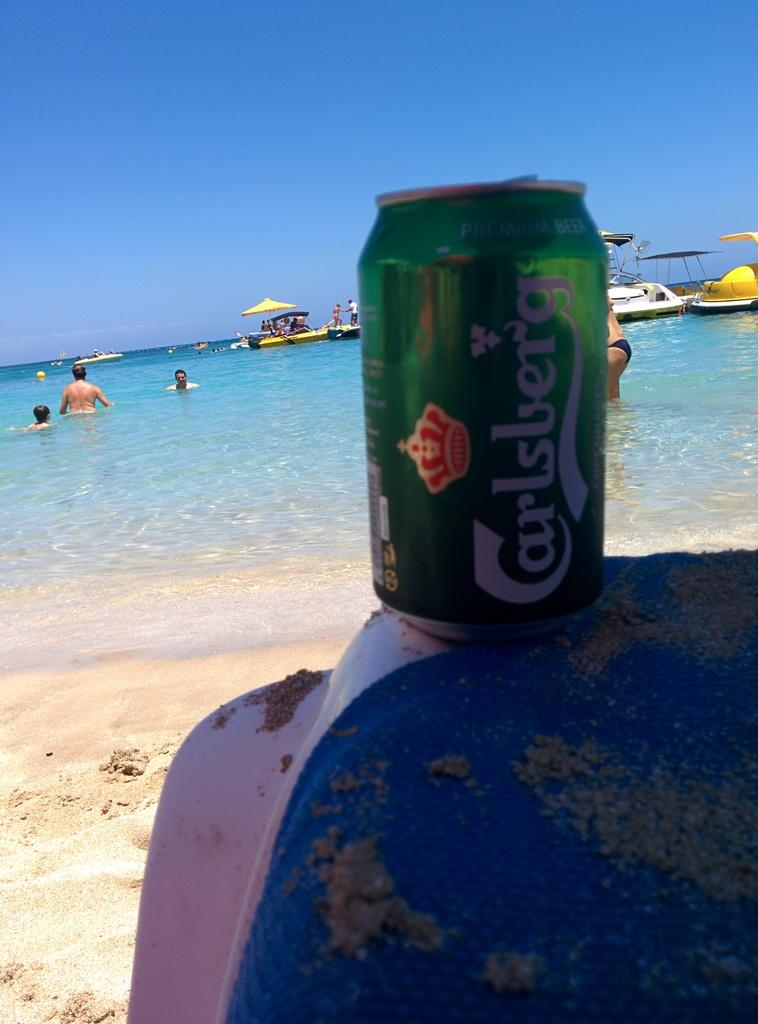<image>
Give a short and clear explanation of the subsequent image. A can of Carlsberg beer at the beach on a sunny day. 